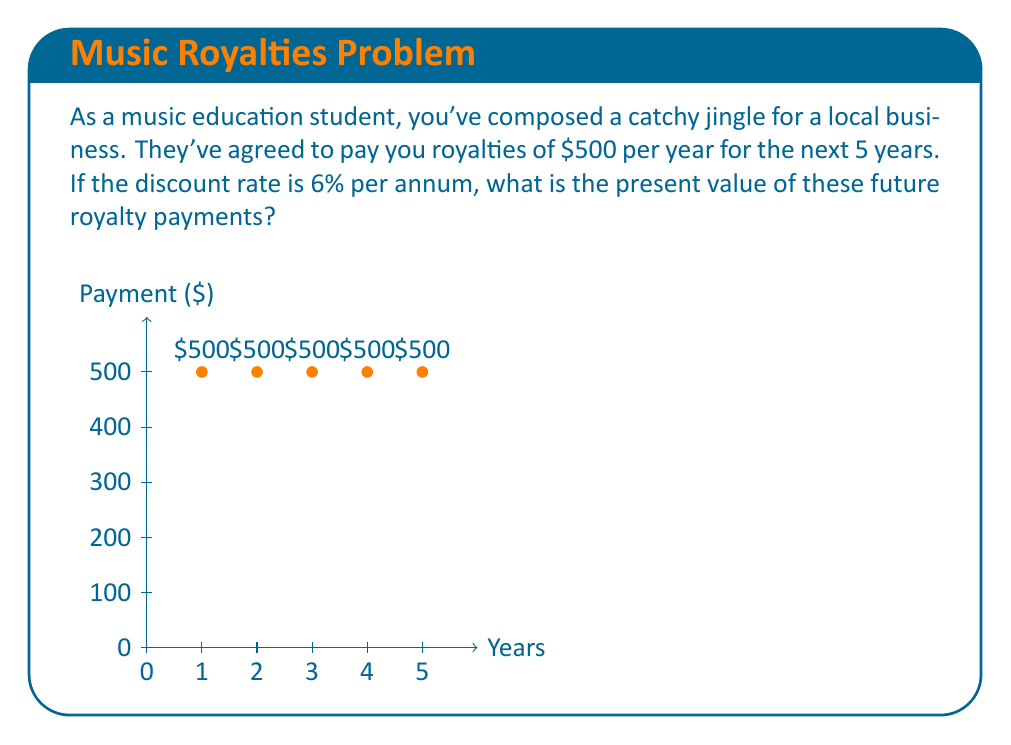Can you solve this math problem? To calculate the present value of future royalty payments, we need to use the present value formula for an annuity:

$$ PV = A \cdot \frac{1 - (1+r)^{-n}}{r} $$

Where:
- $PV$ is the present value
- $A$ is the annual payment (royalty)
- $r$ is the discount rate
- $n$ is the number of years

Given:
- $A = \$500$
- $r = 6\% = 0.06$
- $n = 5$ years

Let's substitute these values into the formula:

$$ PV = 500 \cdot \frac{1 - (1+0.06)^{-5}}{0.06} $$

Now, let's solve step-by-step:

1) First, calculate $(1+0.06)^{-5}$:
   $$(1.06)^{-5} = 0.7472$$

2) Subtract this from 1:
   $$1 - 0.7472 = 0.2528$$

3) Divide by the discount rate:
   $$\frac{0.2528}{0.06} = 4.2133$$

4) Multiply by the annual payment:
   $$500 \cdot 4.2133 = 2106.65$$

Therefore, the present value of the future royalty payments is $2,106.65.
Answer: $2,106.65 